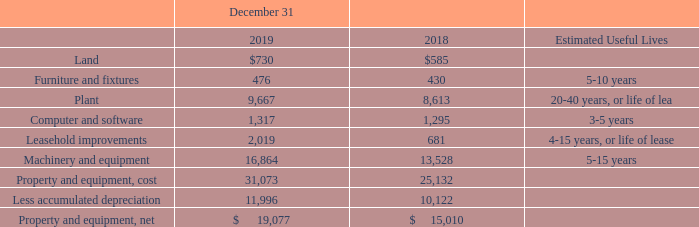NOTE 8. PROPERTY AND EQUIPMENT
The following table details the components of property and equipment (amounts in thousands).
Amounts payable for property and equipment included in accounts payable totaled $0.1 million at December 31, 2019, and $0.2 million at December 31, 2018. During 2019, we financed the purchase of $0.3 million of property with finance leases and equipment notes. Assets which had not yet been placed in service, included in property and equipment, totaled $1.5 million at December 31, 2019, and $2.2 million at December 31, 2018.
What are the respective values of land in 2018 and 2019?
Answer scale should be: thousand. $585, $730. What are the respective values of furniture and fixtures in 2018 and 2019?
Answer scale should be: thousand. 430, 476. What are the respective values of plant in 2018 and 2019?
Answer scale should be: thousand. 8,613, 9,667. What is the change in the land value between 2018 and 2019?
Answer scale should be: thousand. 730 - 585 
Answer: 145. What is the change in the furniture and fixtures value between 2018 and 2019?
Answer scale should be: thousand. 476 - 430 
Answer: 46. What is the change in the plant value between 2018 and 2019?
Answer scale should be: thousand. 9,667 - 8,613 
Answer: 1054. 